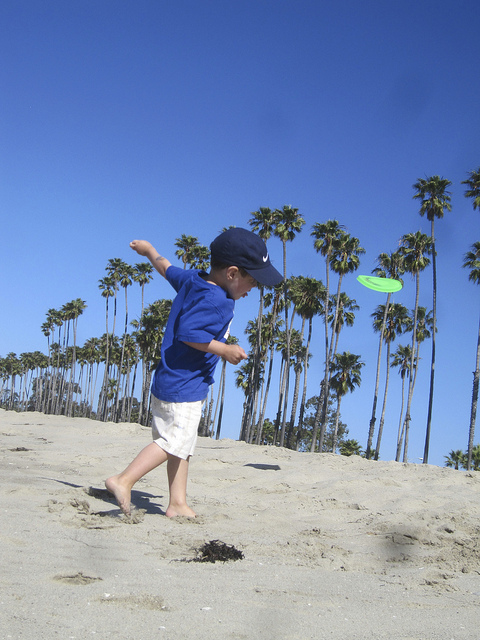<image>What letter is on the boy's hat? It is unclear what letter is on the boy's hat. It could be '0', 'l', 'w', 'j', or a nike logo or symbol. What letter is on the boy's hat? I don't know what letter is on the boy's hat. It can be '0', 'l', 'w', 'nike logo', 'nike symbol' or 'j'. 